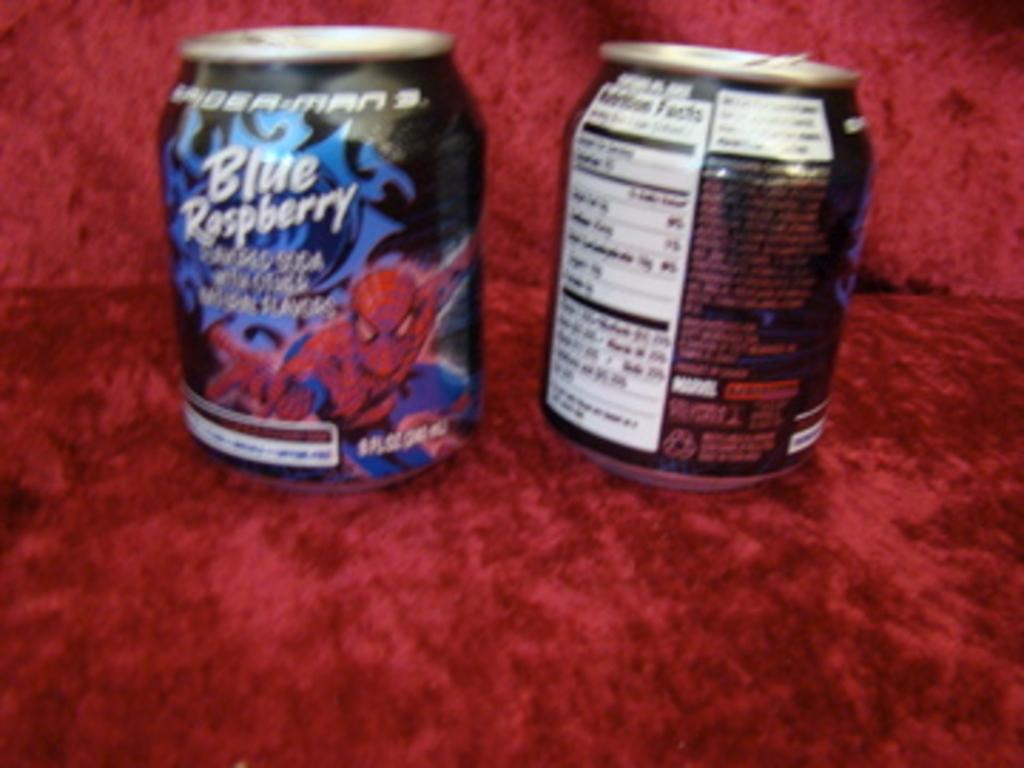Provide a one-sentence caption for the provided image. A beverage that's Blue Raspberry flavored features Spider-Man on its packaging. 